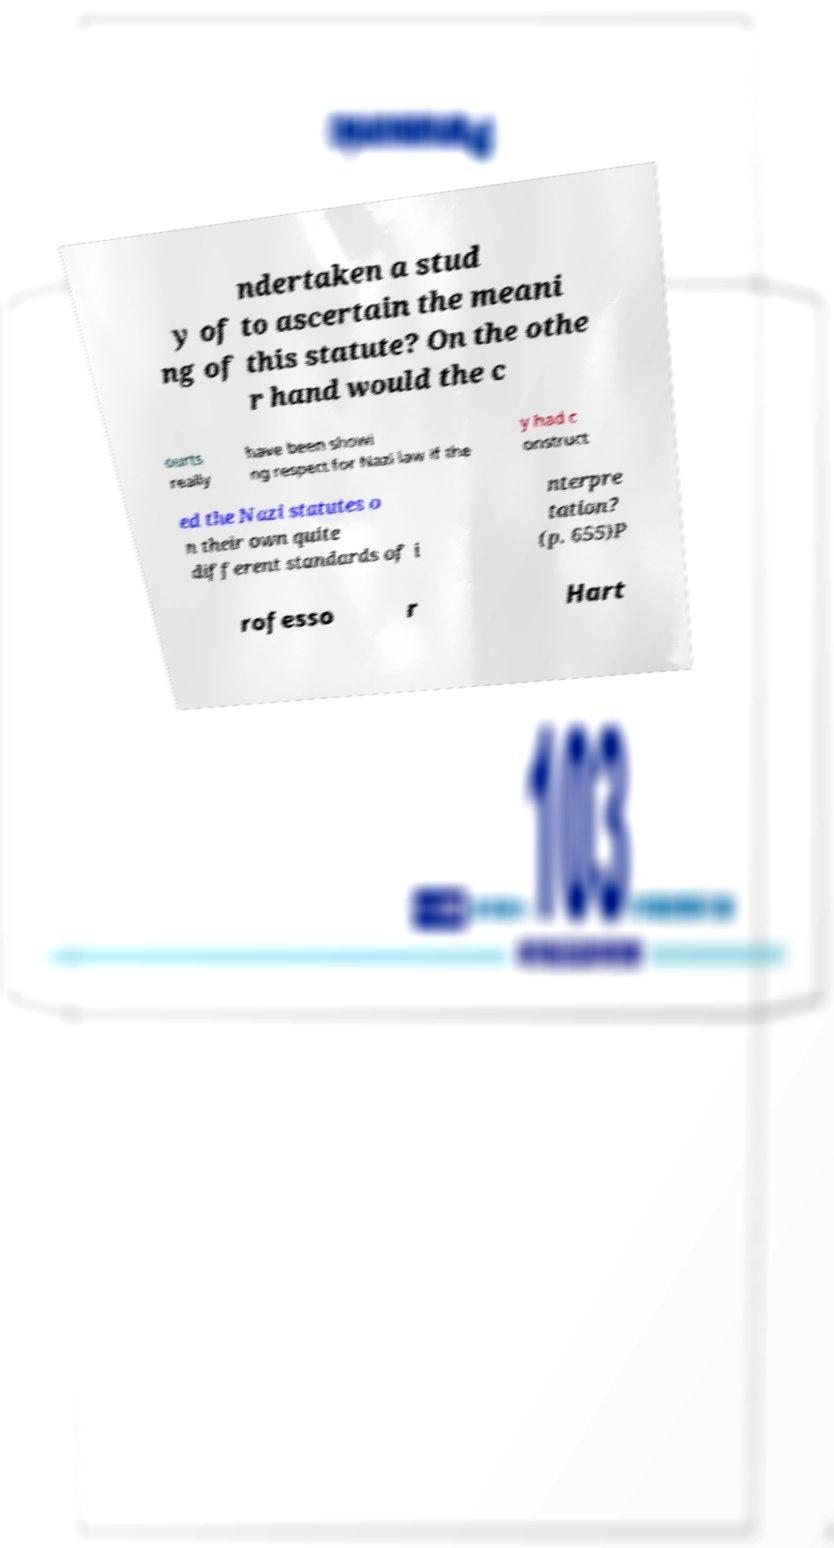For documentation purposes, I need the text within this image transcribed. Could you provide that? ndertaken a stud y of to ascertain the meani ng of this statute? On the othe r hand would the c ourts really have been showi ng respect for Nazi law if the y had c onstruct ed the Nazi statutes o n their own quite different standards of i nterpre tation? (p. 655)P rofesso r Hart 